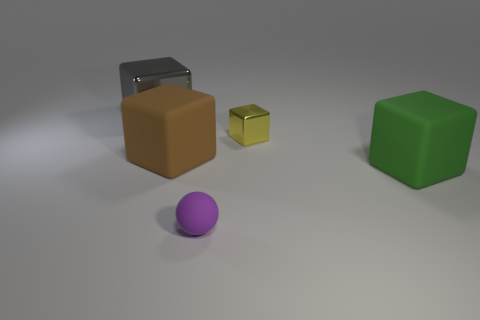What is the material of the other object that is the same size as the yellow metallic object?
Provide a short and direct response. Rubber. What number of tiny objects are gray shiny things or green matte objects?
Make the answer very short. 0. What number of objects are matte blocks that are right of the small purple sphere or blocks that are in front of the gray shiny block?
Offer a terse response. 3. Is the number of large green blocks less than the number of purple rubber blocks?
Provide a short and direct response. No. The green thing that is the same size as the gray metallic object is what shape?
Ensure brevity in your answer.  Cube. What number of objects are there?
Your answer should be compact. 5. How many things are in front of the small metallic cube and on the left side of the small yellow metallic object?
Keep it short and to the point. 2. What is the purple object made of?
Your answer should be compact. Rubber. Is there a brown object?
Offer a very short reply. Yes. What color is the shiny thing that is in front of the gray metal block?
Your response must be concise. Yellow. 